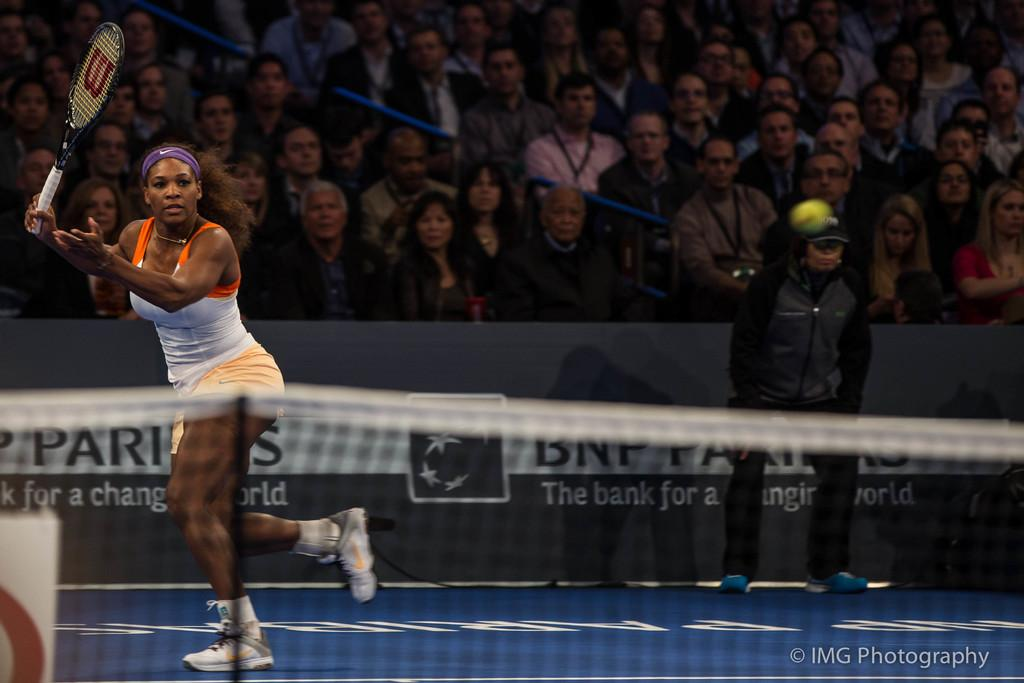What sport is the woman in the image participating in? The woman is playing tennis in the image. What equipment is the woman using to play tennis? The woman is using a tennis racket. Who is watching the tennis match? There is an audience watching the tennis match. Can you describe the man standing in the image? There is a man standing in the image, possibly referred to as "Empire." What unit of measurement is being used to celebrate the birthday in the image? There is no mention of a birthday or any unit of measurement in the image. 